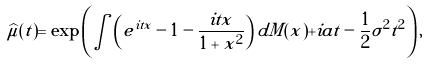Convert formula to latex. <formula><loc_0><loc_0><loc_500><loc_500>\widehat { \mu } ( t ) = \exp \left ( \int \left ( e ^ { i t x } - 1 - \frac { i t x } { 1 + x ^ { 2 } } \right ) d M ( x ) + i a t - \frac { 1 } { 2 } \sigma ^ { 2 } t ^ { 2 } \right ) ,</formula> 